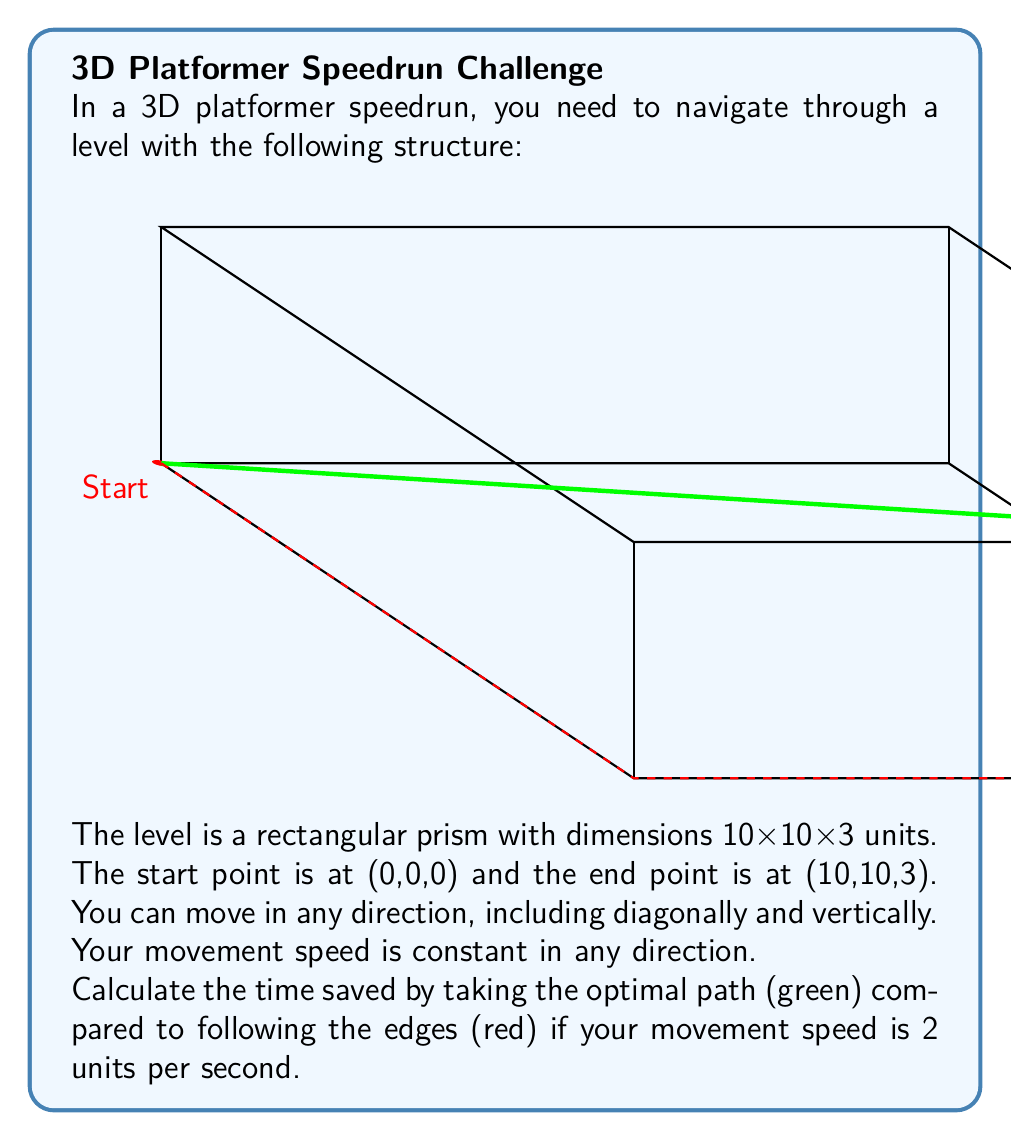Solve this math problem. To solve this problem, we need to follow these steps:

1) First, let's calculate the length of the path following the edges (red path):
   $$(0,0,0) \to (10,0,0) \to (10,10,0) \to (10,10,3)$$
   Length = $10 + 10 + 3 = 23$ units

2) Now, let's calculate the length of the optimal path (green path):
   This is a straight line from (0,0,0) to (10,10,3)
   We can use the 3D distance formula:
   $$d = \sqrt{(x_2-x_1)^2 + (y_2-y_1)^2 + (z_2-z_1)^2}$$
   $$d = \sqrt{(10-0)^2 + (10-0)^2 + (3-0)^2}$$
   $$d = \sqrt{100 + 100 + 9} = \sqrt{209} \approx 14.46 \text{ units}$$

3) Now, let's calculate the time for each path:
   For the edge path: $t_1 = \frac{23}{2} = 11.5$ seconds
   For the optimal path: $t_2 = \frac{14.46}{2} = 7.23$ seconds

4) The time saved is the difference:
   Time saved = $11.5 - 7.23 = 4.27$ seconds
Answer: 4.27 seconds 